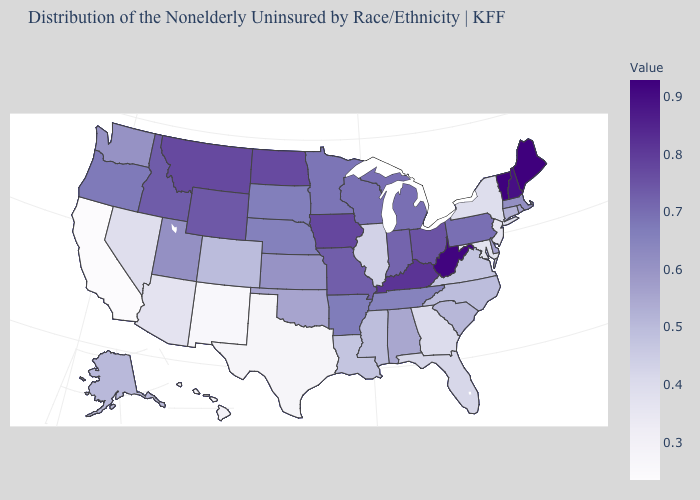Is the legend a continuous bar?
Be succinct. Yes. Does Pennsylvania have a lower value than Maine?
Write a very short answer. Yes. Which states have the highest value in the USA?
Give a very brief answer. Maine. Does Maine have the highest value in the USA?
Be succinct. Yes. Among the states that border Kentucky , does Illinois have the lowest value?
Give a very brief answer. Yes. Does the map have missing data?
Be succinct. No. 